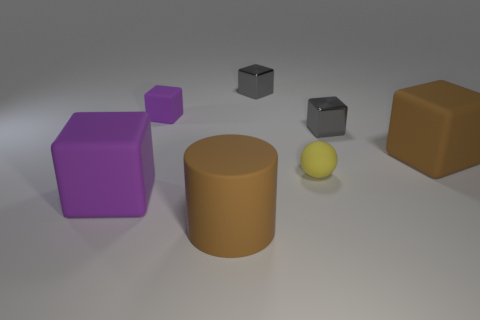Subtract all large purple rubber blocks. How many blocks are left? 4 Subtract all gray cubes. Subtract all blue balls. How many cubes are left? 3 Add 1 yellow spheres. How many objects exist? 8 Subtract all cubes. How many objects are left? 2 Add 7 tiny cubes. How many tiny cubes are left? 10 Add 5 rubber cylinders. How many rubber cylinders exist? 6 Subtract 0 gray spheres. How many objects are left? 7 Subtract all small metallic spheres. Subtract all brown cylinders. How many objects are left? 6 